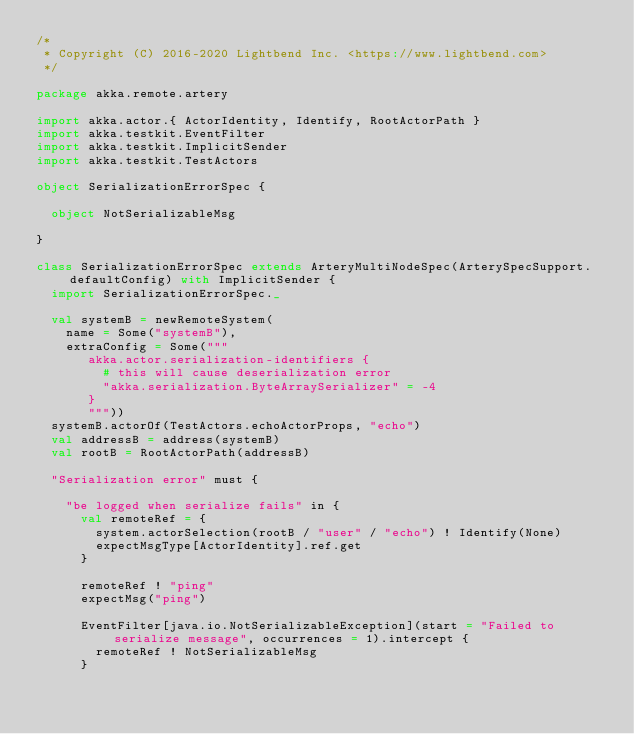<code> <loc_0><loc_0><loc_500><loc_500><_Scala_>/*
 * Copyright (C) 2016-2020 Lightbend Inc. <https://www.lightbend.com>
 */

package akka.remote.artery

import akka.actor.{ ActorIdentity, Identify, RootActorPath }
import akka.testkit.EventFilter
import akka.testkit.ImplicitSender
import akka.testkit.TestActors

object SerializationErrorSpec {

  object NotSerializableMsg

}

class SerializationErrorSpec extends ArteryMultiNodeSpec(ArterySpecSupport.defaultConfig) with ImplicitSender {
  import SerializationErrorSpec._

  val systemB = newRemoteSystem(
    name = Some("systemB"),
    extraConfig = Some("""
       akka.actor.serialization-identifiers {
         # this will cause deserialization error
         "akka.serialization.ByteArraySerializer" = -4
       }
       """))
  systemB.actorOf(TestActors.echoActorProps, "echo")
  val addressB = address(systemB)
  val rootB = RootActorPath(addressB)

  "Serialization error" must {

    "be logged when serialize fails" in {
      val remoteRef = {
        system.actorSelection(rootB / "user" / "echo") ! Identify(None)
        expectMsgType[ActorIdentity].ref.get
      }

      remoteRef ! "ping"
      expectMsg("ping")

      EventFilter[java.io.NotSerializableException](start = "Failed to serialize message", occurrences = 1).intercept {
        remoteRef ! NotSerializableMsg
      }
</code> 